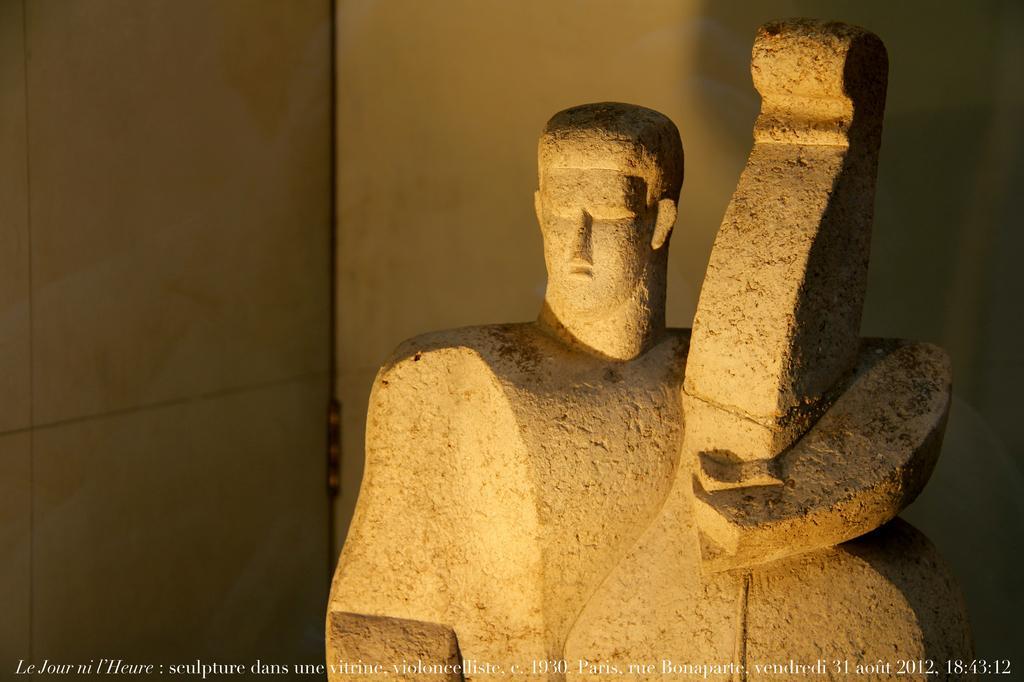Could you give a brief overview of what you see in this image? In this picture we can see a statue, walls and at the bottom of this picture we can see some text. 